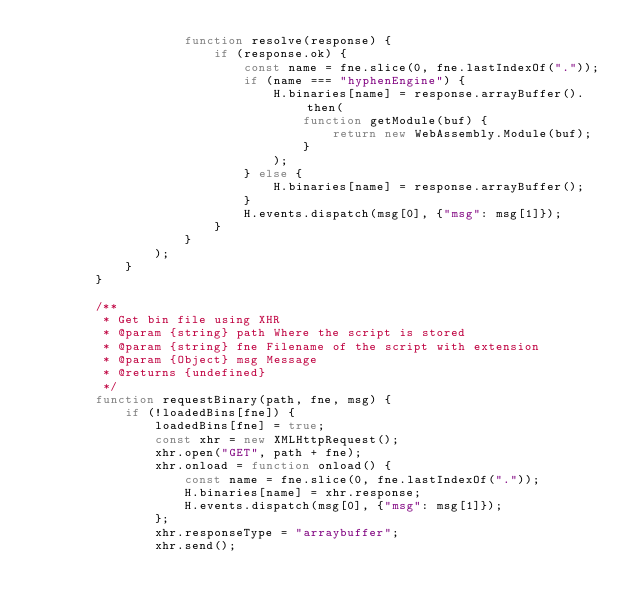Convert code to text. <code><loc_0><loc_0><loc_500><loc_500><_JavaScript_>                    function resolve(response) {
                        if (response.ok) {
                            const name = fne.slice(0, fne.lastIndexOf("."));
                            if (name === "hyphenEngine") {
                                H.binaries[name] = response.arrayBuffer().then(
                                    function getModule(buf) {
                                        return new WebAssembly.Module(buf);
                                    }
                                );
                            } else {
                                H.binaries[name] = response.arrayBuffer();
                            }
                            H.events.dispatch(msg[0], {"msg": msg[1]});
                        }
                    }
                );
            }
        }

        /**
         * Get bin file using XHR
         * @param {string} path Where the script is stored
         * @param {string} fne Filename of the script with extension
         * @param {Object} msg Message
         * @returns {undefined}
         */
        function requestBinary(path, fne, msg) {
            if (!loadedBins[fne]) {
                loadedBins[fne] = true;
                const xhr = new XMLHttpRequest();
                xhr.open("GET", path + fne);
                xhr.onload = function onload() {
                    const name = fne.slice(0, fne.lastIndexOf("."));
                    H.binaries[name] = xhr.response;
                    H.events.dispatch(msg[0], {"msg": msg[1]});
                };
                xhr.responseType = "arraybuffer";
                xhr.send();</code> 